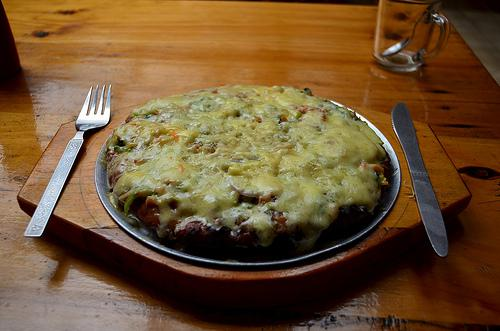Question: where is the fork?
Choices:
A. In the sink.
B. Beside the plate.
C. In the drawer.
D. In the dish washing machine.
Answer with the letter. Answer: B Question: where is the table?
Choices:
A. In the dining room.
B. On the floor.
C. In the kitchen.
D. Under the plate.
Answer with the letter. Answer: D Question: what is the fork made of?
Choices:
A. Plastic.
B. Ceramic.
C. Metal.
D. Wood.
Answer with the letter. Answer: C 